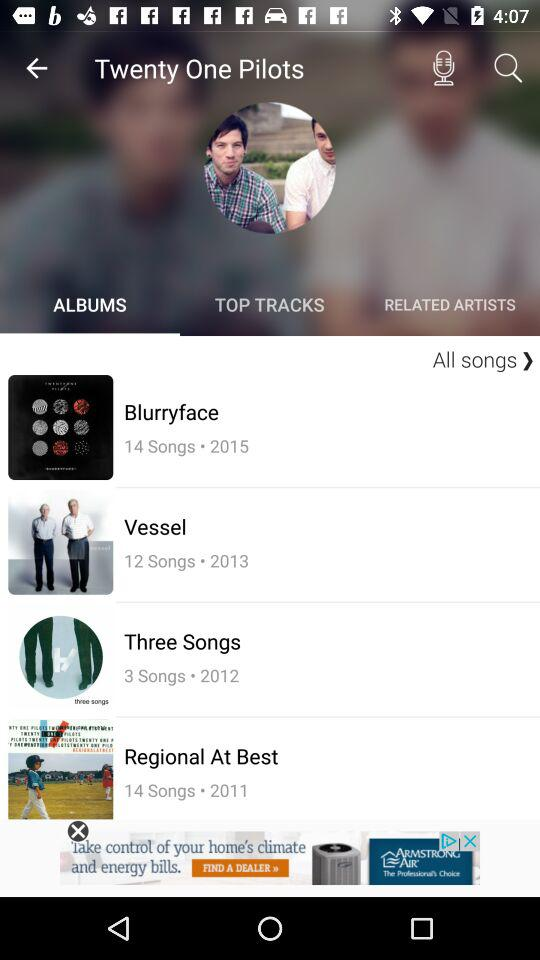How many more songs are on the album Blurryface than on the album Three Songs?
Answer the question using a single word or phrase. 11 